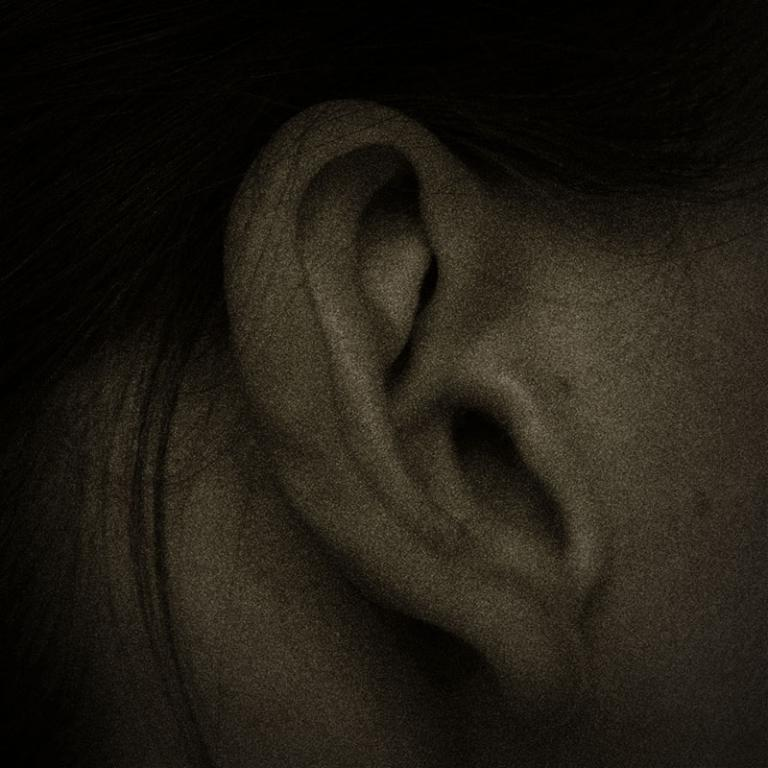What part of the body is visible in the image? There is an ear visible in the image. What type of quartz is present in the image? There is no quartz present in the image; it features an ear. What type of metal is visible in the image? There is no metal visible in the image; it features an ear. 